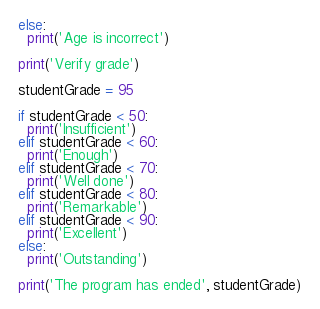Convert code to text. <code><loc_0><loc_0><loc_500><loc_500><_Python_>else:
  print('Age is incorrect')

print('Verify grade')

studentGrade = 95

if studentGrade < 50:
  print('Insufficient')
elif studentGrade < 60:
  print('Enough')
elif studentGrade < 70:
  print('Well done')
elif studentGrade < 80:
  print('Remarkable')
elif studentGrade < 90:
  print('Excellent')
else:
  print('Outstanding')

print('The program has ended', studentGrade)
</code> 